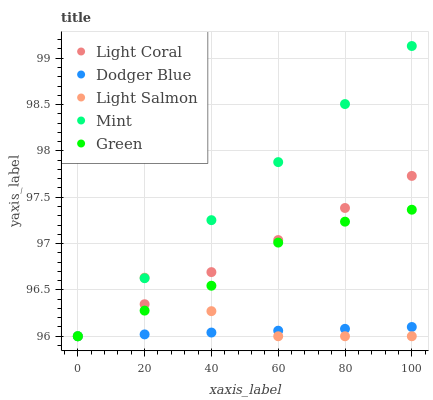Does Dodger Blue have the minimum area under the curve?
Answer yes or no. Yes. Does Mint have the maximum area under the curve?
Answer yes or no. Yes. Does Light Salmon have the minimum area under the curve?
Answer yes or no. No. Does Light Salmon have the maximum area under the curve?
Answer yes or no. No. Is Dodger Blue the smoothest?
Answer yes or no. Yes. Is Light Salmon the roughest?
Answer yes or no. Yes. Is Mint the smoothest?
Answer yes or no. No. Is Mint the roughest?
Answer yes or no. No. Does Light Coral have the lowest value?
Answer yes or no. Yes. Does Mint have the highest value?
Answer yes or no. Yes. Does Light Salmon have the highest value?
Answer yes or no. No. Does Light Coral intersect Light Salmon?
Answer yes or no. Yes. Is Light Coral less than Light Salmon?
Answer yes or no. No. Is Light Coral greater than Light Salmon?
Answer yes or no. No. 